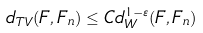<formula> <loc_0><loc_0><loc_500><loc_500>d _ { T V } ( F , F _ { n } ) \leq C d _ { W } ^ { 1 - \varepsilon } ( F , F _ { n } )</formula> 